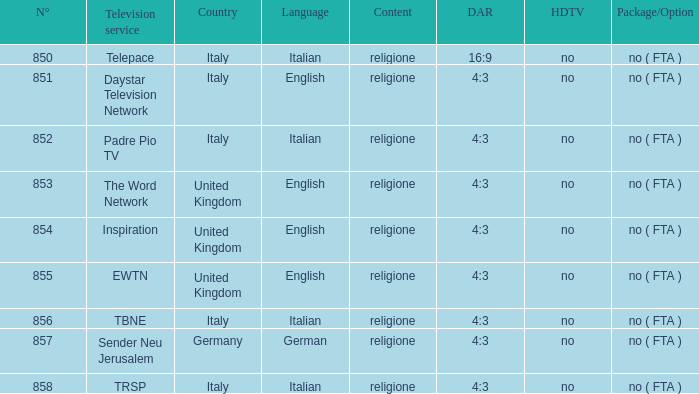What is the count of italian television services with a number exceeding 856.0? TRSP. 